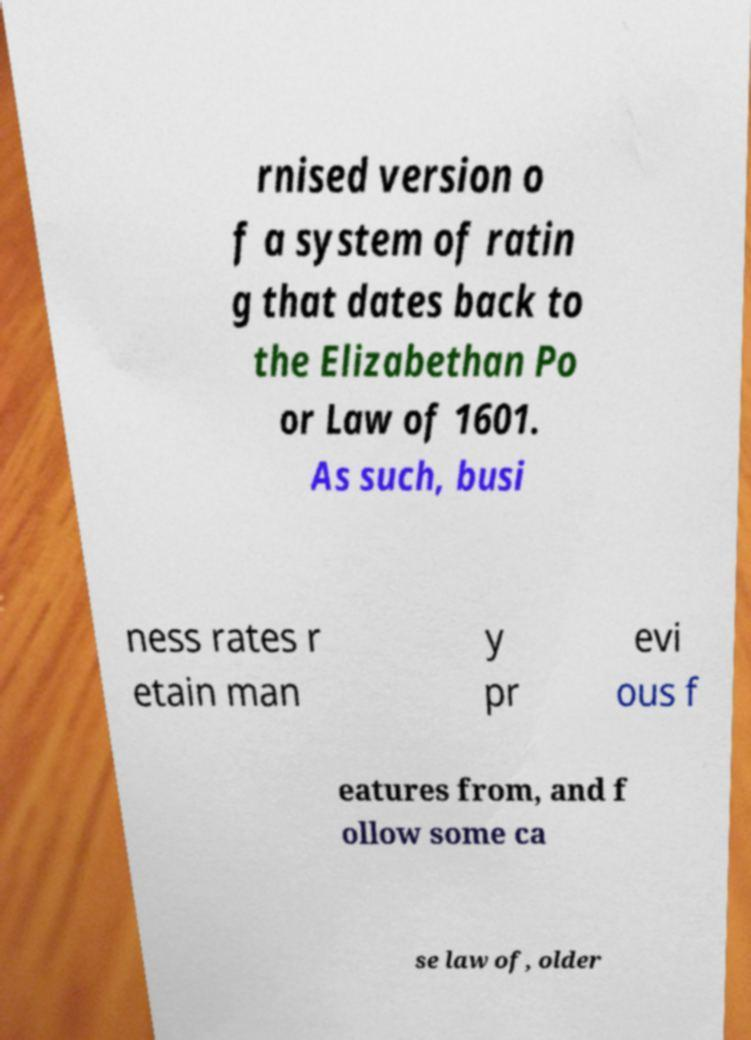Could you assist in decoding the text presented in this image and type it out clearly? rnised version o f a system of ratin g that dates back to the Elizabethan Po or Law of 1601. As such, busi ness rates r etain man y pr evi ous f eatures from, and f ollow some ca se law of, older 